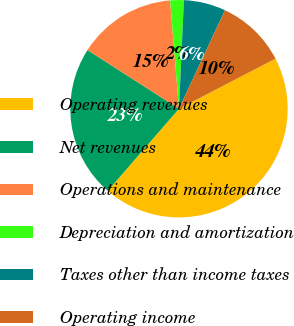Convert chart to OTSL. <chart><loc_0><loc_0><loc_500><loc_500><pie_chart><fcel>Operating revenues<fcel>Net revenues<fcel>Operations and maintenance<fcel>Depreciation and amortization<fcel>Taxes other than income taxes<fcel>Operating income<nl><fcel>43.99%<fcel>22.7%<fcel>14.62%<fcel>2.03%<fcel>6.23%<fcel>10.43%<nl></chart> 